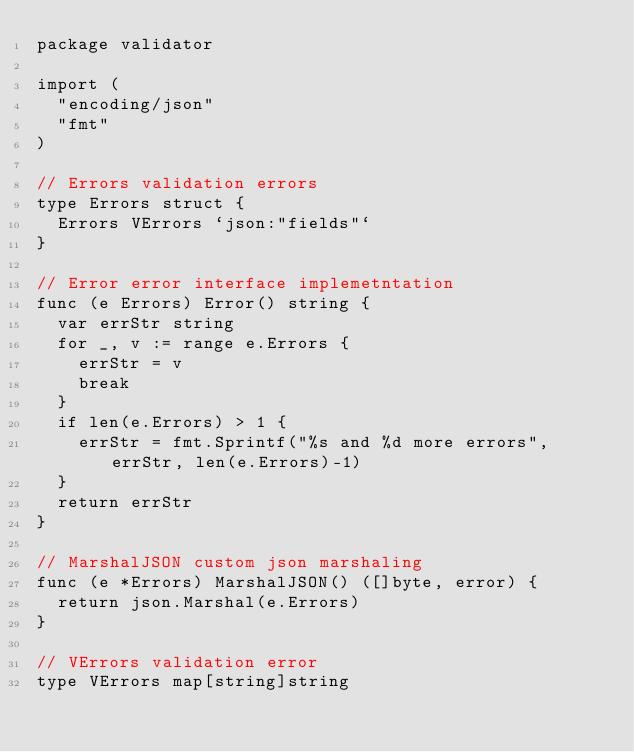<code> <loc_0><loc_0><loc_500><loc_500><_Go_>package validator

import (
	"encoding/json"
	"fmt"
)

// Errors validation errors
type Errors struct {
	Errors VErrors `json:"fields"`
}

// Error error interface implemetntation
func (e Errors) Error() string {
	var errStr string
	for _, v := range e.Errors {
		errStr = v
		break
	}
	if len(e.Errors) > 1 {
		errStr = fmt.Sprintf("%s and %d more errors", errStr, len(e.Errors)-1)
	}
	return errStr
}

// MarshalJSON custom json marshaling
func (e *Errors) MarshalJSON() ([]byte, error) {
	return json.Marshal(e.Errors)
}

// VErrors validation error
type VErrors map[string]string
</code> 